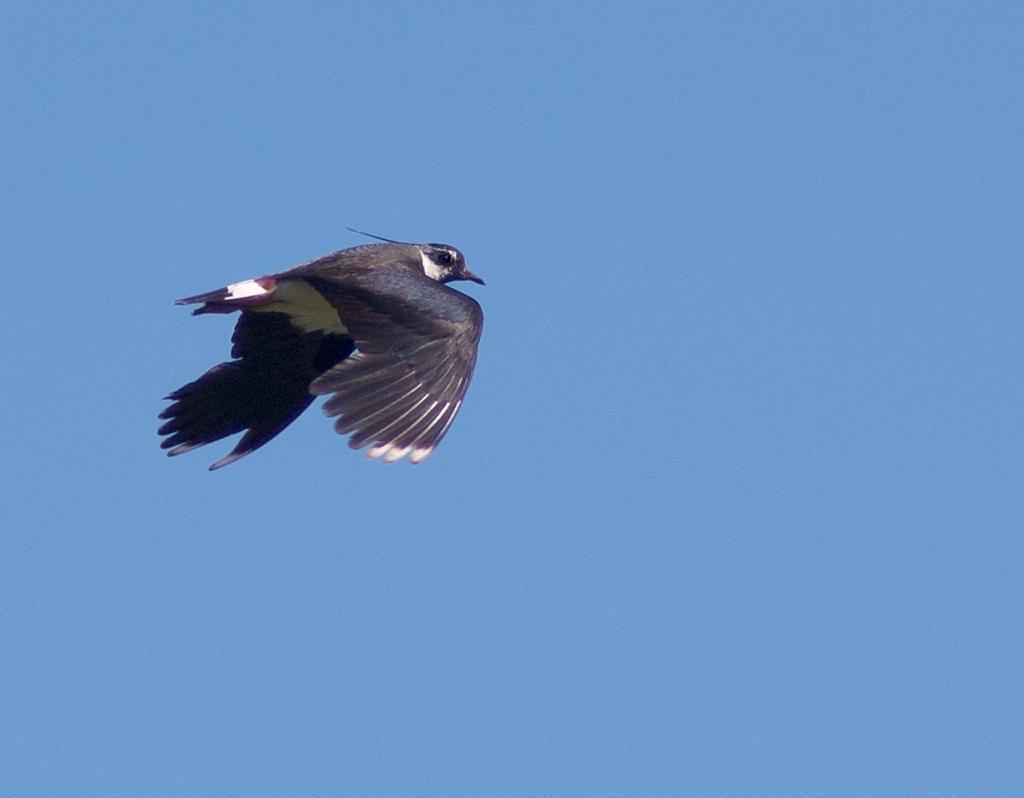Can you describe this image briefly? There is a black color bird flying in the air. In the background, there is blue sky. 